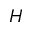Convert formula to latex. <formula><loc_0><loc_0><loc_500><loc_500>H</formula> 